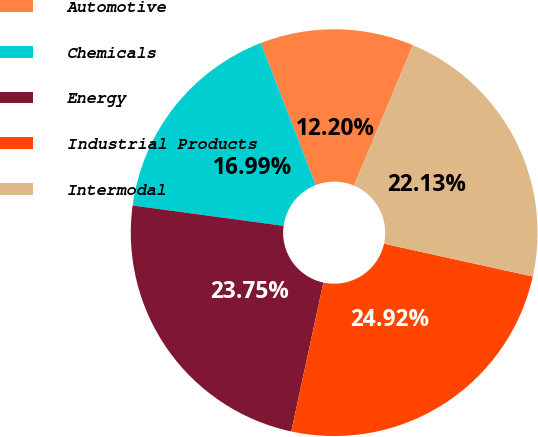<chart> <loc_0><loc_0><loc_500><loc_500><pie_chart><fcel>Automotive<fcel>Chemicals<fcel>Energy<fcel>Industrial Products<fcel>Intermodal<nl><fcel>12.2%<fcel>16.99%<fcel>23.75%<fcel>24.92%<fcel>22.13%<nl></chart> 